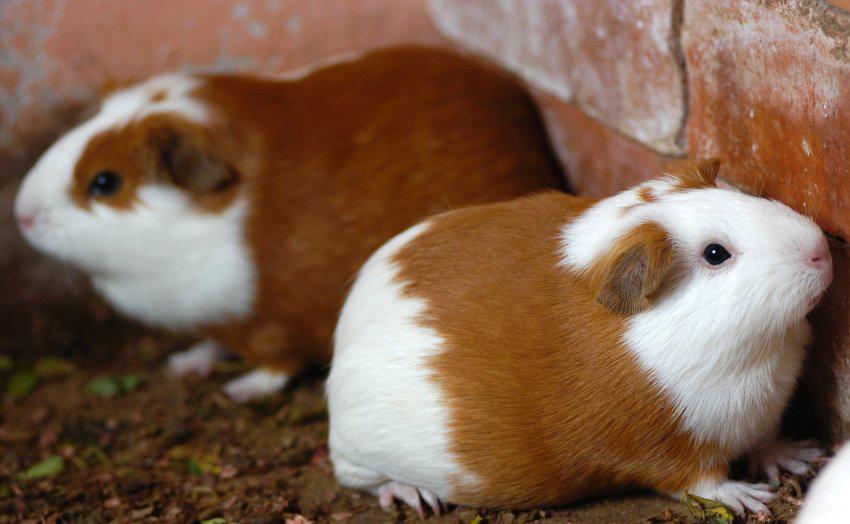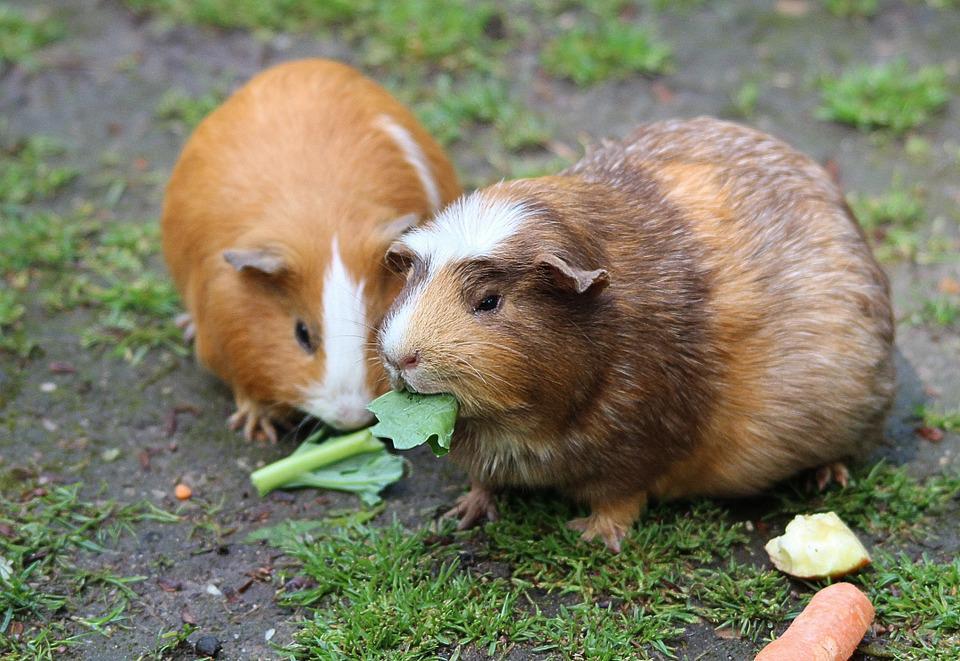The first image is the image on the left, the second image is the image on the right. Examine the images to the left and right. Is the description "An image shows a pair of hamsters nibbling on something green." accurate? Answer yes or no. Yes. The first image is the image on the left, the second image is the image on the right. Given the left and right images, does the statement "There is at least one guinea pig eating a green food item" hold true? Answer yes or no. Yes. 